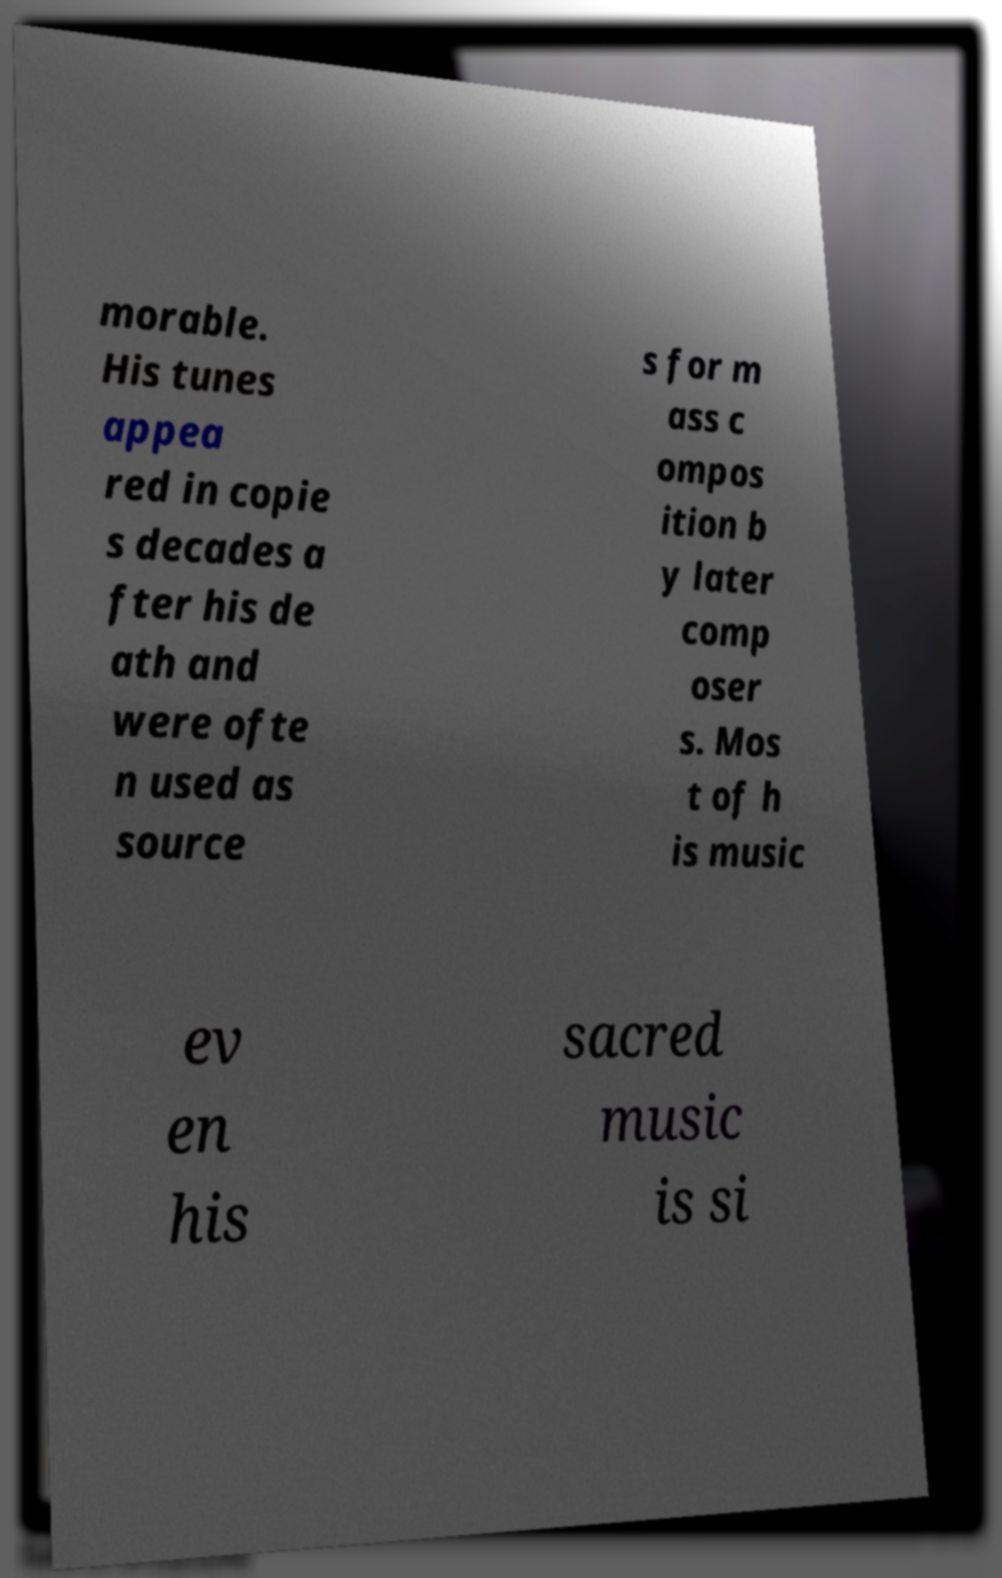Please identify and transcribe the text found in this image. morable. His tunes appea red in copie s decades a fter his de ath and were ofte n used as source s for m ass c ompos ition b y later comp oser s. Mos t of h is music ev en his sacred music is si 